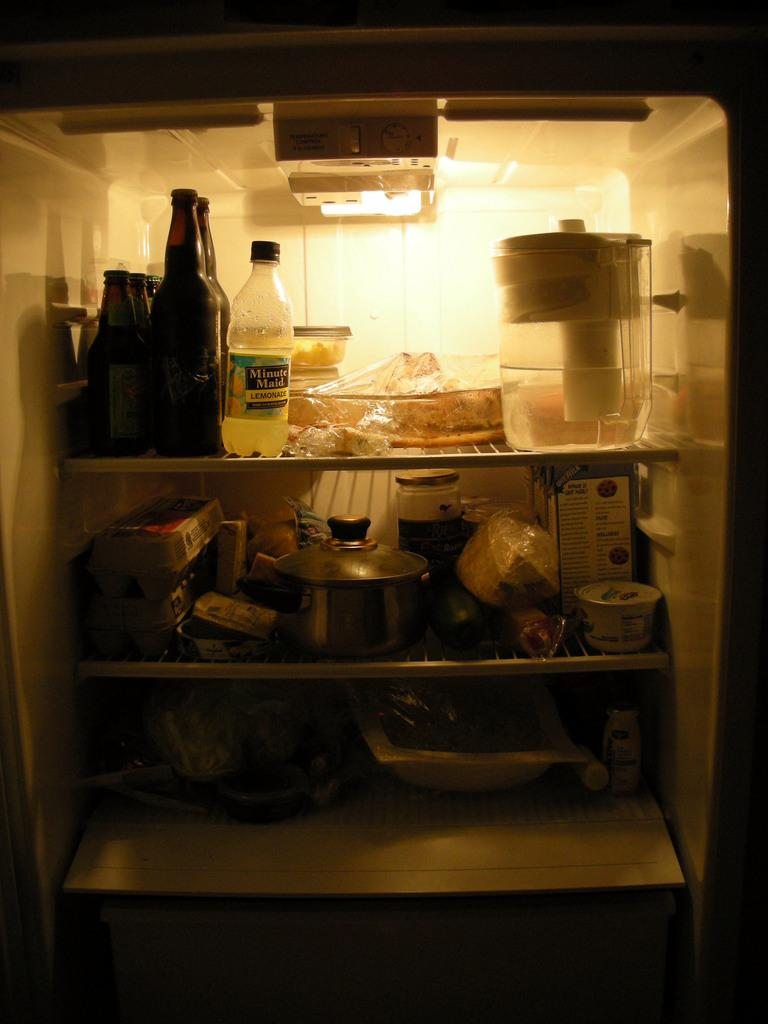<image>
Offer a succinct explanation of the picture presented. A refrigerator is stocked with food and products, including Minute Maid lemonade. 